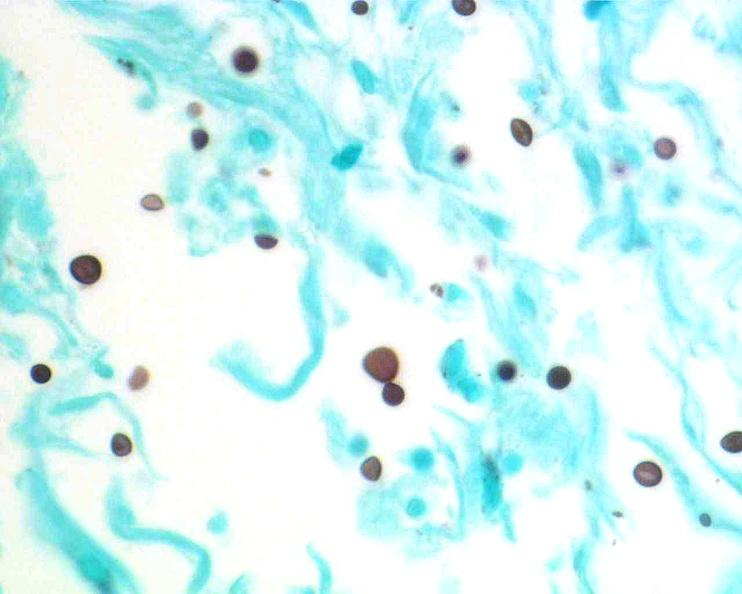do gms stain?
Answer the question using a single word or phrase. Yes 